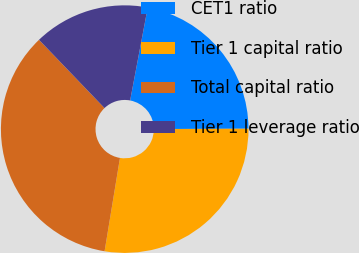<chart> <loc_0><loc_0><loc_500><loc_500><pie_chart><fcel>CET1 ratio<fcel>Tier 1 capital ratio<fcel>Total capital ratio<fcel>Tier 1 leverage ratio<nl><fcel>21.97%<fcel>27.65%<fcel>35.23%<fcel>15.15%<nl></chart> 